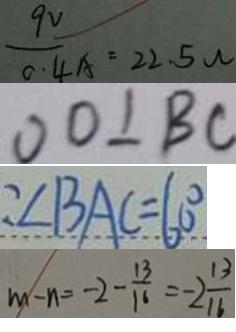Convert formula to latex. <formula><loc_0><loc_0><loc_500><loc_500>\frac { 9 V } { 0 . 4 A } = 2 2 . 5 w 
 O D \bot B C 
 : \angle B A C = 6 0 ^ { \circ } 
 m - n = - 2 - \frac { 1 3 } { 1 6 } = - 2 \frac { 1 3 } { 1 6 }</formula> 